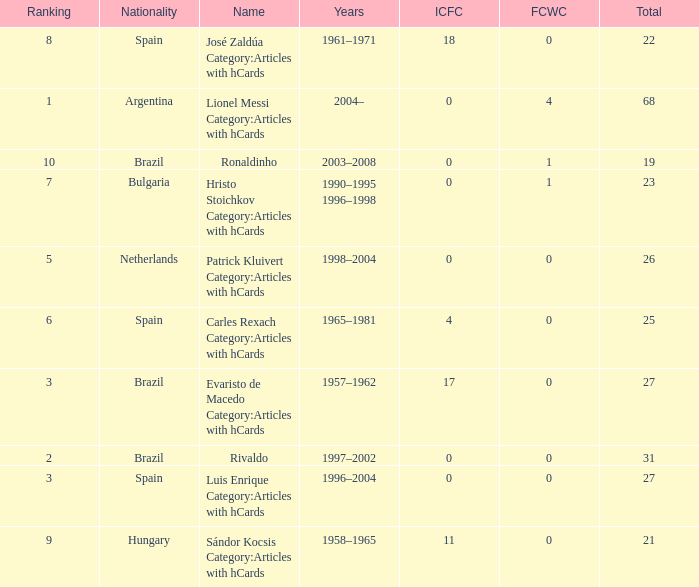What is the highest number of FCWC in the Years of 1958–1965, and an ICFC smaller than 11? None. 